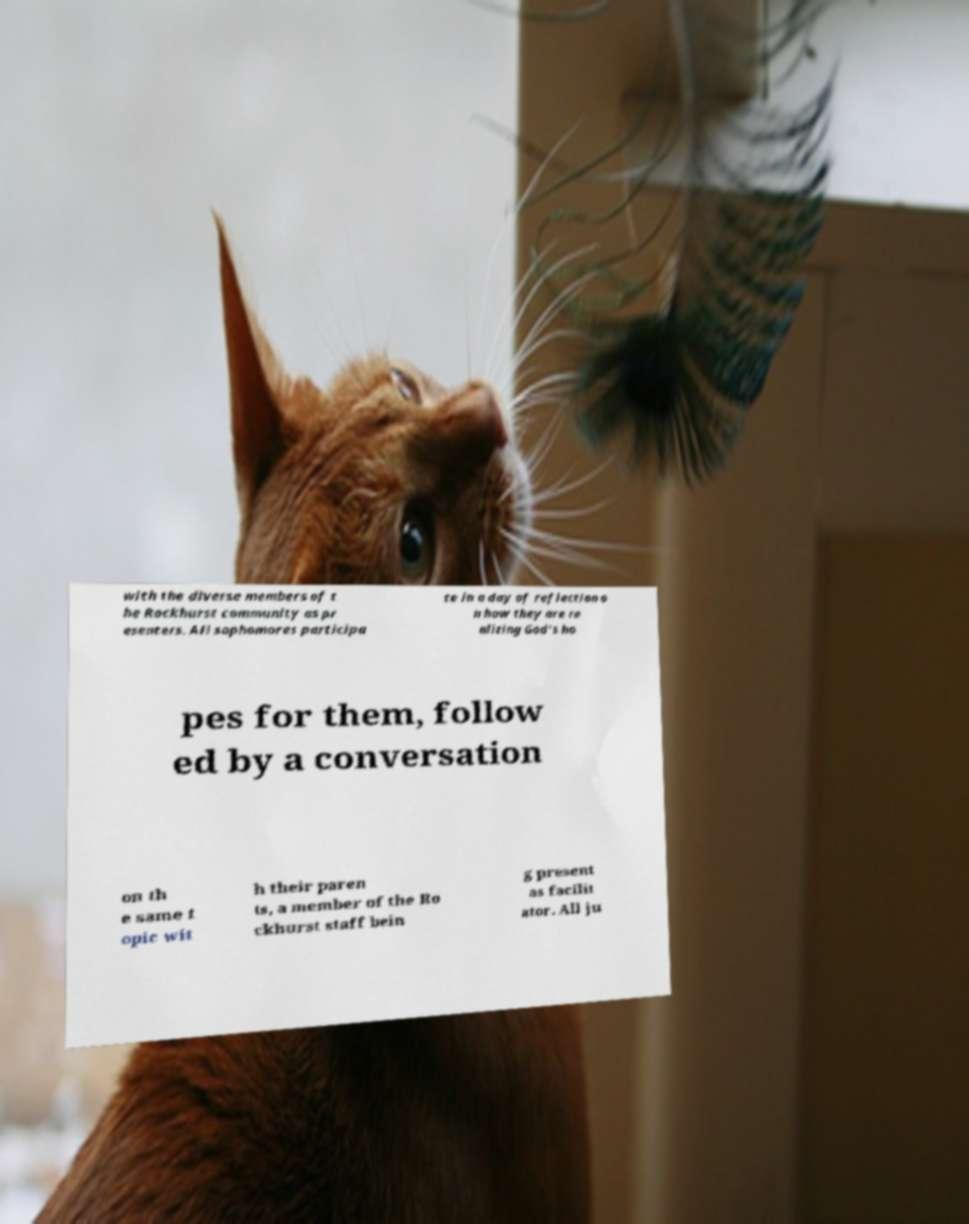For documentation purposes, I need the text within this image transcribed. Could you provide that? with the diverse members of t he Rockhurst community as pr esenters. All sophomores participa te in a day of reflection o n how they are re alizing God's ho pes for them, follow ed by a conversation on th e same t opic wit h their paren ts, a member of the Ro ckhurst staff bein g present as facilit ator. All ju 